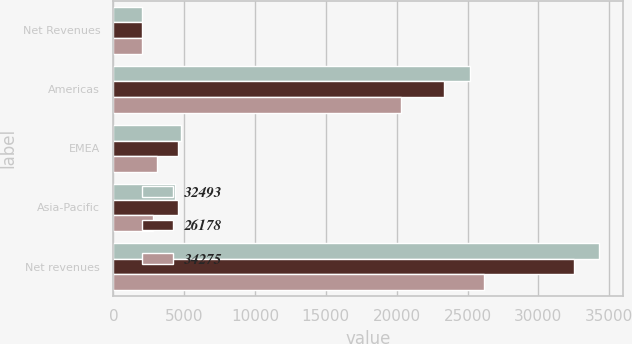Convert chart. <chart><loc_0><loc_0><loc_500><loc_500><stacked_bar_chart><ecel><fcel>Net Revenues<fcel>Americas<fcel>EMEA<fcel>Asia-Pacific<fcel>Net revenues<nl><fcel>32493<fcel>2014<fcel>25140<fcel>4772<fcel>4363<fcel>34275<nl><fcel>26178<fcel>2013<fcel>23358<fcel>4542<fcel>4593<fcel>32493<nl><fcel>34275<fcel>2012<fcel>20276<fcel>3078<fcel>2824<fcel>26178<nl></chart> 